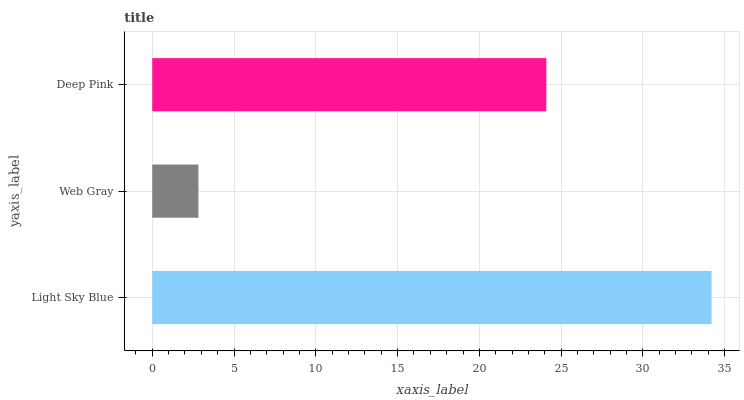Is Web Gray the minimum?
Answer yes or no. Yes. Is Light Sky Blue the maximum?
Answer yes or no. Yes. Is Deep Pink the minimum?
Answer yes or no. No. Is Deep Pink the maximum?
Answer yes or no. No. Is Deep Pink greater than Web Gray?
Answer yes or no. Yes. Is Web Gray less than Deep Pink?
Answer yes or no. Yes. Is Web Gray greater than Deep Pink?
Answer yes or no. No. Is Deep Pink less than Web Gray?
Answer yes or no. No. Is Deep Pink the high median?
Answer yes or no. Yes. Is Deep Pink the low median?
Answer yes or no. Yes. Is Web Gray the high median?
Answer yes or no. No. Is Web Gray the low median?
Answer yes or no. No. 